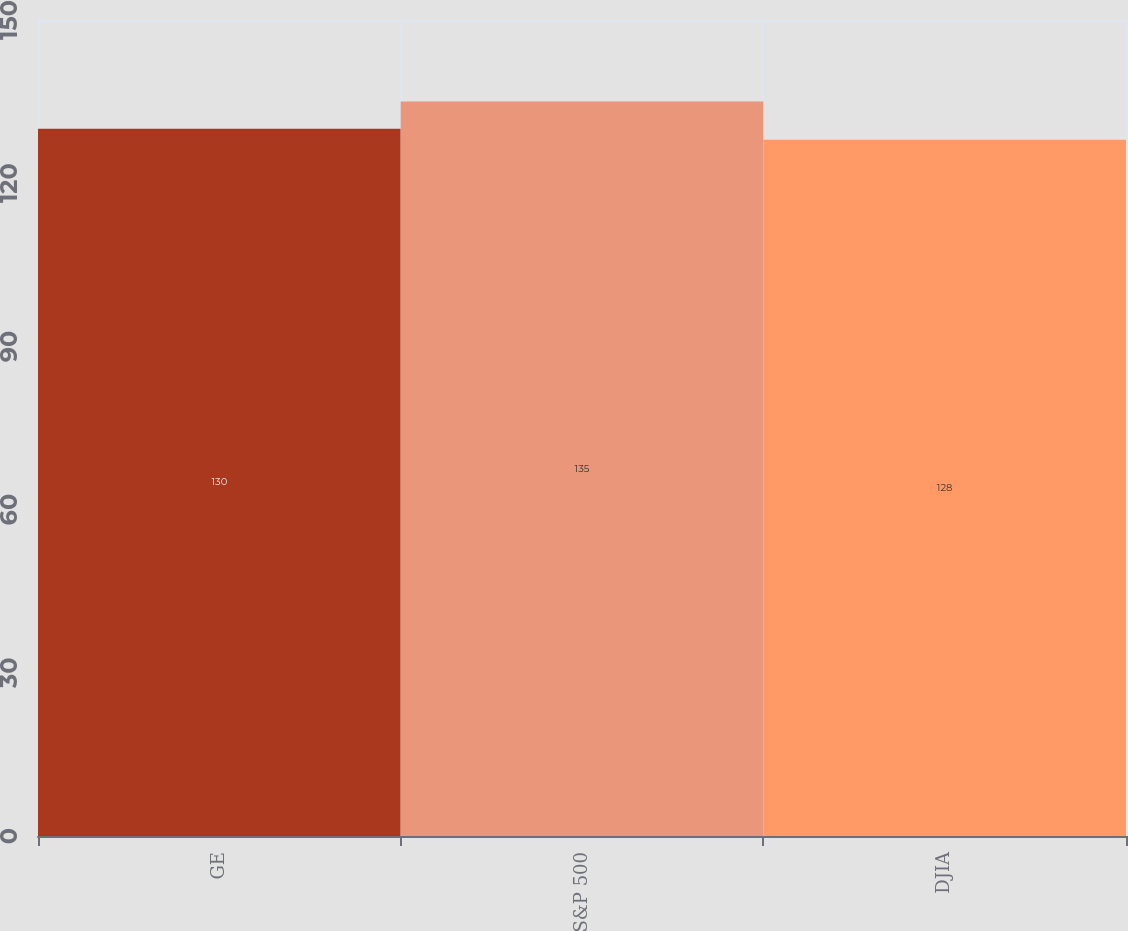Convert chart to OTSL. <chart><loc_0><loc_0><loc_500><loc_500><bar_chart><fcel>GE<fcel>S&P 500<fcel>DJIA<nl><fcel>130<fcel>135<fcel>128<nl></chart> 